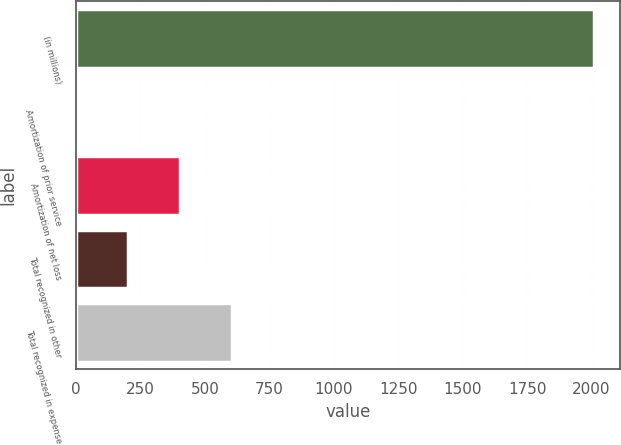Convert chart. <chart><loc_0><loc_0><loc_500><loc_500><bar_chart><fcel>(in millions)<fcel>Amortization of prior service<fcel>Amortization of net loss<fcel>Total recognized in other<fcel>Total recognized in expense<nl><fcel>2009<fcel>1<fcel>402.6<fcel>201.8<fcel>603.4<nl></chart> 